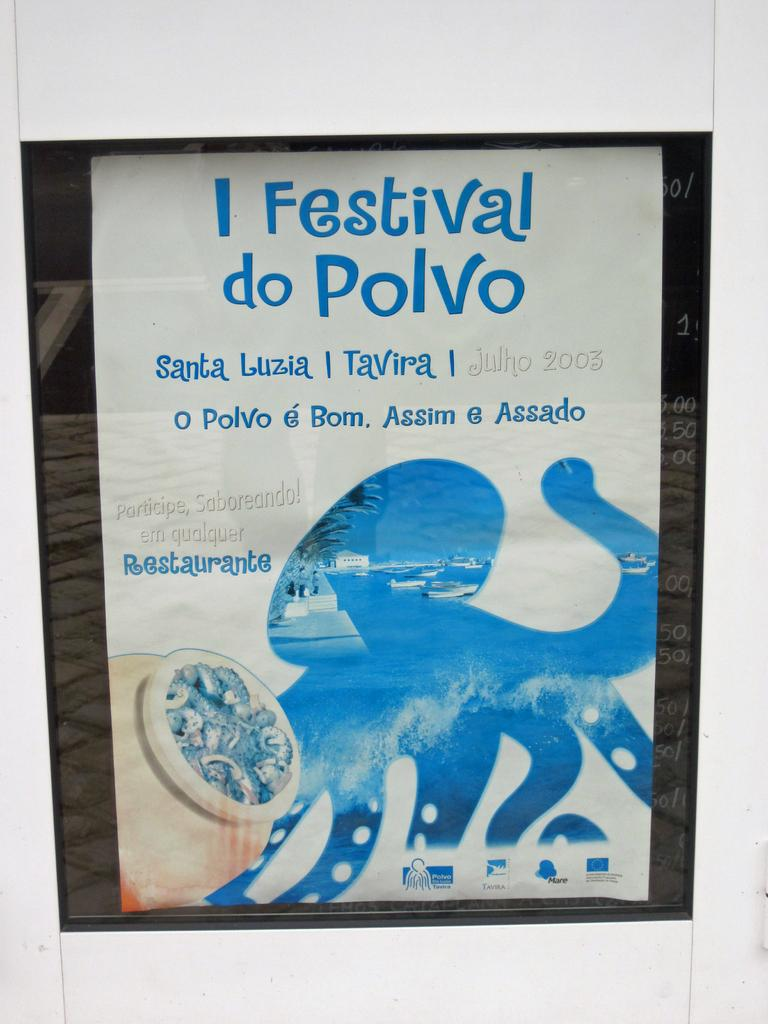<image>
Provide a brief description of the given image. A poster for I Festival do Polvo has an octopus on it. 